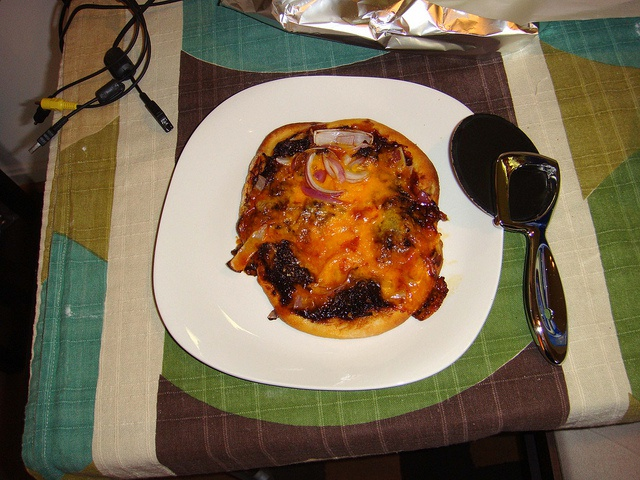Describe the objects in this image and their specific colors. I can see dining table in lightgray, olive, black, and maroon tones, pizza in maroon, brown, and red tones, and spoon in maroon, black, olive, and gray tones in this image. 